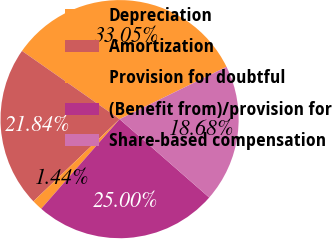Convert chart. <chart><loc_0><loc_0><loc_500><loc_500><pie_chart><fcel>Depreciation<fcel>Amortization<fcel>Provision for doubtful<fcel>(Benefit from)/provision for<fcel>Share-based compensation<nl><fcel>33.05%<fcel>21.84%<fcel>1.44%<fcel>25.0%<fcel>18.68%<nl></chart> 